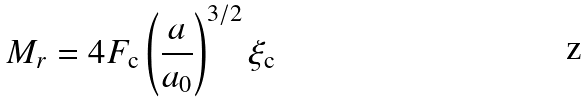<formula> <loc_0><loc_0><loc_500><loc_500>M _ { r } = 4 F _ { \text {c} } \left ( \frac { a } { a _ { 0 } } \right ) ^ { 3 / 2 } \xi _ { \text {c} }</formula> 